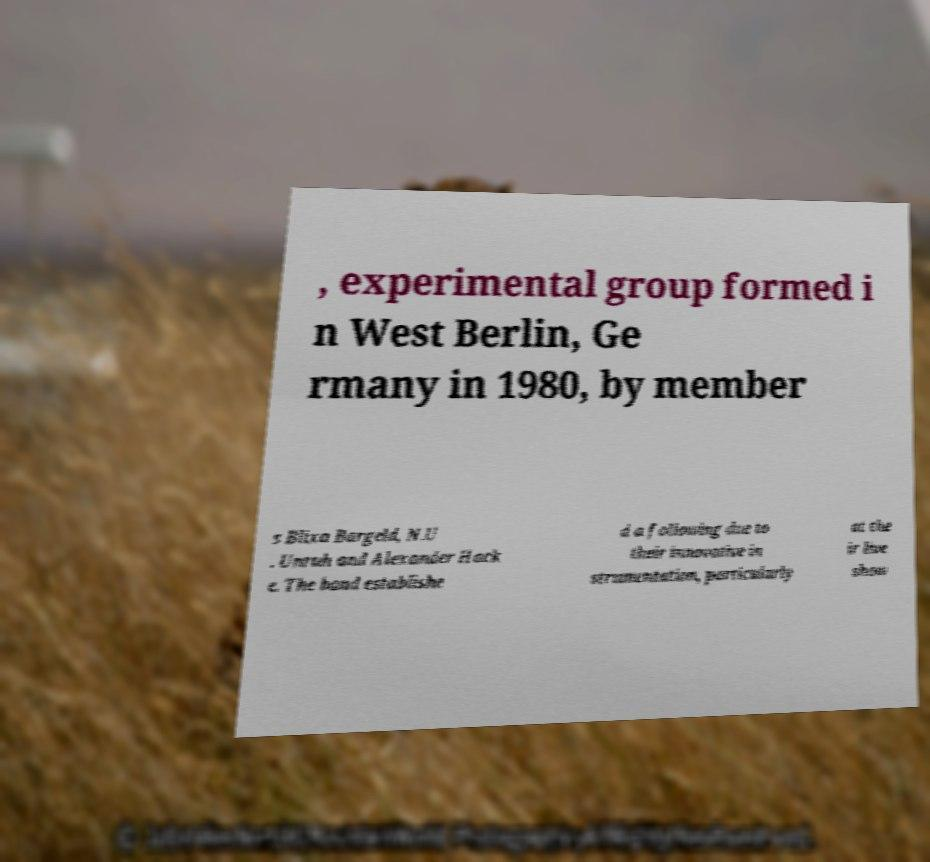Could you extract and type out the text from this image? , experimental group formed i n West Berlin, Ge rmany in 1980, by member s Blixa Bargeld, N.U . Unruh and Alexander Hack e. The band establishe d a following due to their innovative in strumentation, particularly at the ir live show 